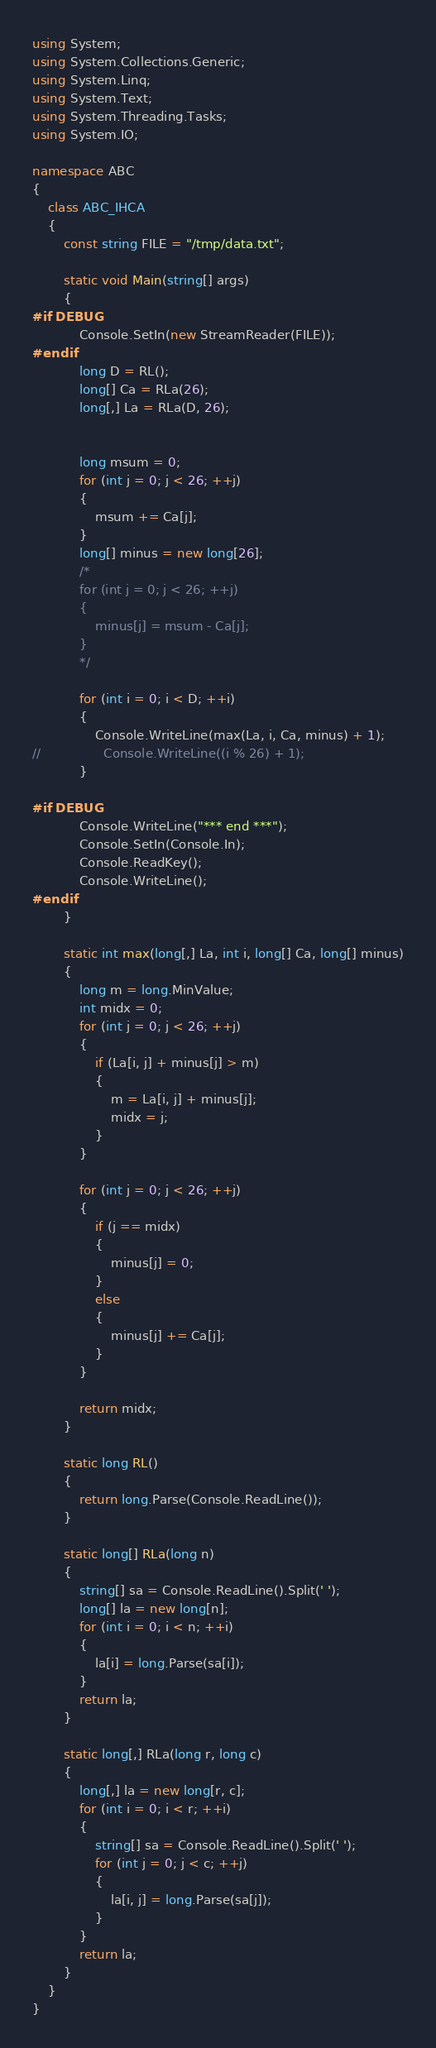Convert code to text. <code><loc_0><loc_0><loc_500><loc_500><_C#_>using System;
using System.Collections.Generic;
using System.Linq;
using System.Text;
using System.Threading.Tasks;
using System.IO;

namespace ABC
{
    class ABC_IHCA
    {
        const string FILE = "/tmp/data.txt";

        static void Main(string[] args)
        {
#if DEBUG
            Console.SetIn(new StreamReader(FILE));
#endif
            long D = RL();
            long[] Ca = RLa(26);
            long[,] La = RLa(D, 26);


            long msum = 0;
            for (int j = 0; j < 26; ++j)
            {
                msum += Ca[j];
            }
            long[] minus = new long[26];
            /*
            for (int j = 0; j < 26; ++j)
            {
                minus[j] = msum - Ca[j];
            }
            */

            for (int i = 0; i < D; ++i)
            {
                Console.WriteLine(max(La, i, Ca, minus) + 1);
//                Console.WriteLine((i % 26) + 1);
            }

#if DEBUG
            Console.WriteLine("*** end ***");
            Console.SetIn(Console.In);
            Console.ReadKey();
            Console.WriteLine();
#endif
        }

        static int max(long[,] La, int i, long[] Ca, long[] minus)
        {
            long m = long.MinValue;
            int midx = 0;
            for (int j = 0; j < 26; ++j)
            {
                if (La[i, j] + minus[j] > m)
                {
                    m = La[i, j] + minus[j];
                    midx = j;
                }
            }

            for (int j = 0; j < 26; ++j)
            {
                if (j == midx)
                {
                    minus[j] = 0;
                }
                else
                {
                    minus[j] += Ca[j];
                }
            }

            return midx;
        }

        static long RL()
        {
            return long.Parse(Console.ReadLine());
        }

        static long[] RLa(long n)
        {
            string[] sa = Console.ReadLine().Split(' ');
            long[] la = new long[n];
            for (int i = 0; i < n; ++i)
            {
                la[i] = long.Parse(sa[i]);
            }
            return la;
        }

        static long[,] RLa(long r, long c)
        {
            long[,] la = new long[r, c];
            for (int i = 0; i < r; ++i)
            {
                string[] sa = Console.ReadLine().Split(' ');
                for (int j = 0; j < c; ++j)
                {
                    la[i, j] = long.Parse(sa[j]);
                }
            }
            return la;
        }
    }
}
</code> 